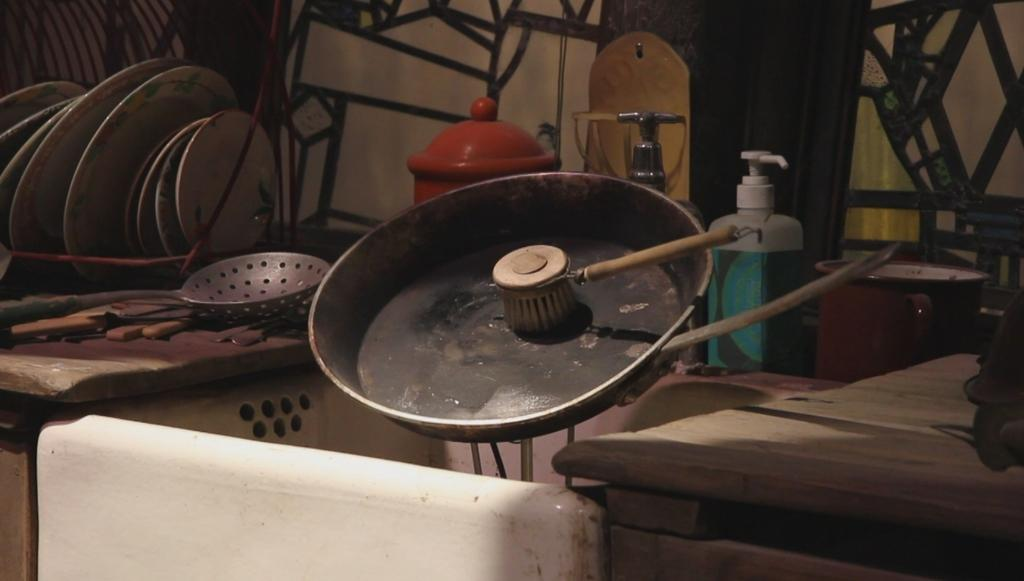What type of room is depicted in the image? The image appears to be a kitchen. What objects can be seen in the kitchen? There are vessels, a brush, and a dish wash liquid bottle in the image. Is there any furniture in the kitchen? Yes, there is a table on the side in the image. How many legs can be seen on the skate in the image? There is no skate present in the image, so it is not possible to determine the number of legs on a skate. 